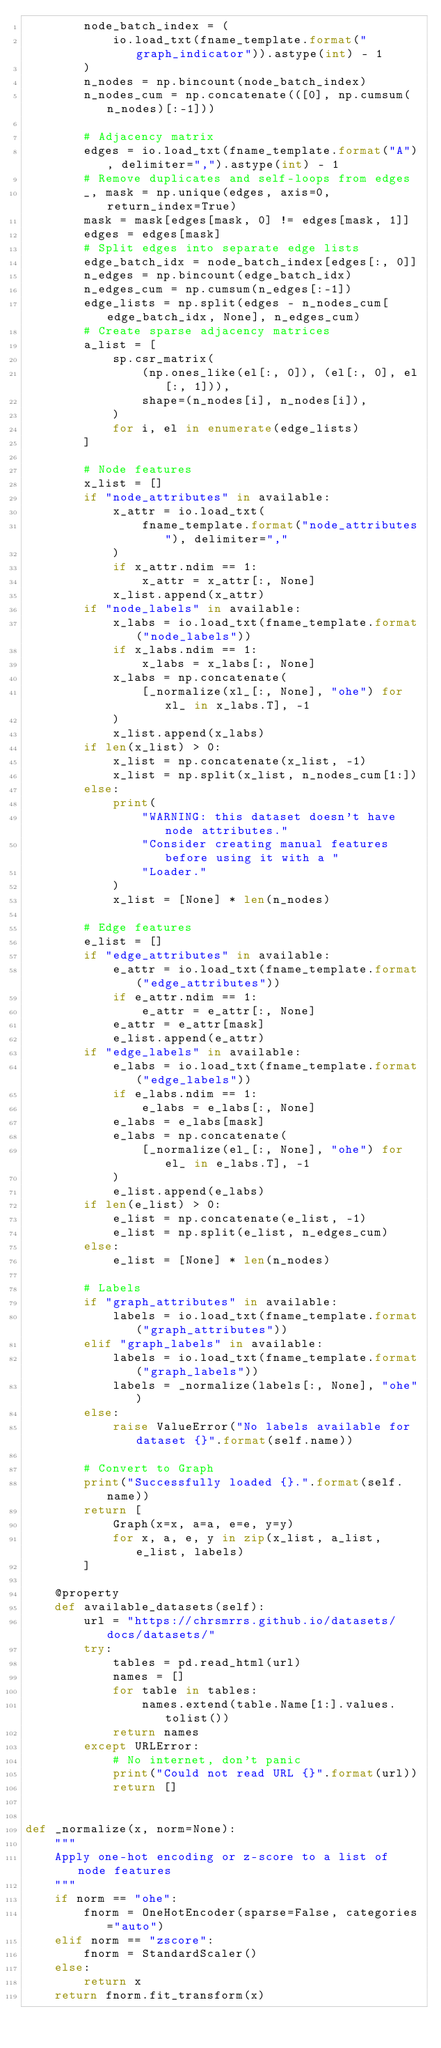Convert code to text. <code><loc_0><loc_0><loc_500><loc_500><_Python_>        node_batch_index = (
            io.load_txt(fname_template.format("graph_indicator")).astype(int) - 1
        )
        n_nodes = np.bincount(node_batch_index)
        n_nodes_cum = np.concatenate(([0], np.cumsum(n_nodes)[:-1]))

        # Adjacency matrix
        edges = io.load_txt(fname_template.format("A"), delimiter=",").astype(int) - 1
        # Remove duplicates and self-loops from edges
        _, mask = np.unique(edges, axis=0, return_index=True)
        mask = mask[edges[mask, 0] != edges[mask, 1]]
        edges = edges[mask]
        # Split edges into separate edge lists
        edge_batch_idx = node_batch_index[edges[:, 0]]
        n_edges = np.bincount(edge_batch_idx)
        n_edges_cum = np.cumsum(n_edges[:-1])
        edge_lists = np.split(edges - n_nodes_cum[edge_batch_idx, None], n_edges_cum)
        # Create sparse adjacency matrices
        a_list = [
            sp.csr_matrix(
                (np.ones_like(el[:, 0]), (el[:, 0], el[:, 1])),
                shape=(n_nodes[i], n_nodes[i]),
            )
            for i, el in enumerate(edge_lists)
        ]

        # Node features
        x_list = []
        if "node_attributes" in available:
            x_attr = io.load_txt(
                fname_template.format("node_attributes"), delimiter=","
            )
            if x_attr.ndim == 1:
                x_attr = x_attr[:, None]
            x_list.append(x_attr)
        if "node_labels" in available:
            x_labs = io.load_txt(fname_template.format("node_labels"))
            if x_labs.ndim == 1:
                x_labs = x_labs[:, None]
            x_labs = np.concatenate(
                [_normalize(xl_[:, None], "ohe") for xl_ in x_labs.T], -1
            )
            x_list.append(x_labs)
        if len(x_list) > 0:
            x_list = np.concatenate(x_list, -1)
            x_list = np.split(x_list, n_nodes_cum[1:])
        else:
            print(
                "WARNING: this dataset doesn't have node attributes."
                "Consider creating manual features before using it with a "
                "Loader."
            )
            x_list = [None] * len(n_nodes)

        # Edge features
        e_list = []
        if "edge_attributes" in available:
            e_attr = io.load_txt(fname_template.format("edge_attributes"))
            if e_attr.ndim == 1:
                e_attr = e_attr[:, None]
            e_attr = e_attr[mask]
            e_list.append(e_attr)
        if "edge_labels" in available:
            e_labs = io.load_txt(fname_template.format("edge_labels"))
            if e_labs.ndim == 1:
                e_labs = e_labs[:, None]
            e_labs = e_labs[mask]
            e_labs = np.concatenate(
                [_normalize(el_[:, None], "ohe") for el_ in e_labs.T], -1
            )
            e_list.append(e_labs)
        if len(e_list) > 0:
            e_list = np.concatenate(e_list, -1)
            e_list = np.split(e_list, n_edges_cum)
        else:
            e_list = [None] * len(n_nodes)

        # Labels
        if "graph_attributes" in available:
            labels = io.load_txt(fname_template.format("graph_attributes"))
        elif "graph_labels" in available:
            labels = io.load_txt(fname_template.format("graph_labels"))
            labels = _normalize(labels[:, None], "ohe")
        else:
            raise ValueError("No labels available for dataset {}".format(self.name))

        # Convert to Graph
        print("Successfully loaded {}.".format(self.name))
        return [
            Graph(x=x, a=a, e=e, y=y)
            for x, a, e, y in zip(x_list, a_list, e_list, labels)
        ]

    @property
    def available_datasets(self):
        url = "https://chrsmrrs.github.io/datasets/docs/datasets/"
        try:
            tables = pd.read_html(url)
            names = []
            for table in tables:
                names.extend(table.Name[1:].values.tolist())
            return names
        except URLError:
            # No internet, don't panic
            print("Could not read URL {}".format(url))
            return []


def _normalize(x, norm=None):
    """
    Apply one-hot encoding or z-score to a list of node features
    """
    if norm == "ohe":
        fnorm = OneHotEncoder(sparse=False, categories="auto")
    elif norm == "zscore":
        fnorm = StandardScaler()
    else:
        return x
    return fnorm.fit_transform(x)
</code> 